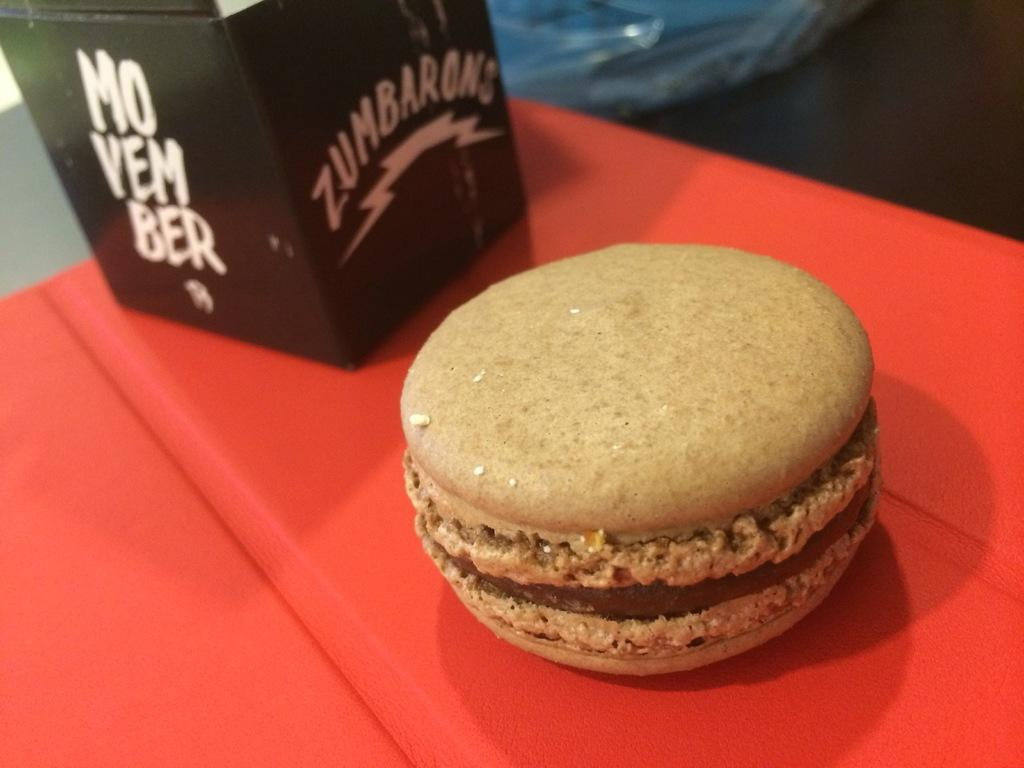What type of food item is visible in the image? There is a food item in the image, but its specific type cannot be determined from the provided facts. What other object can be seen in the image besides the food item? There is a black box in the image. What color is the surface that is visible in the image? The red surface is present in the image. What time is displayed on the hour in the image? There is no hour or clock present in the image, so it is not possible to determine the time. 